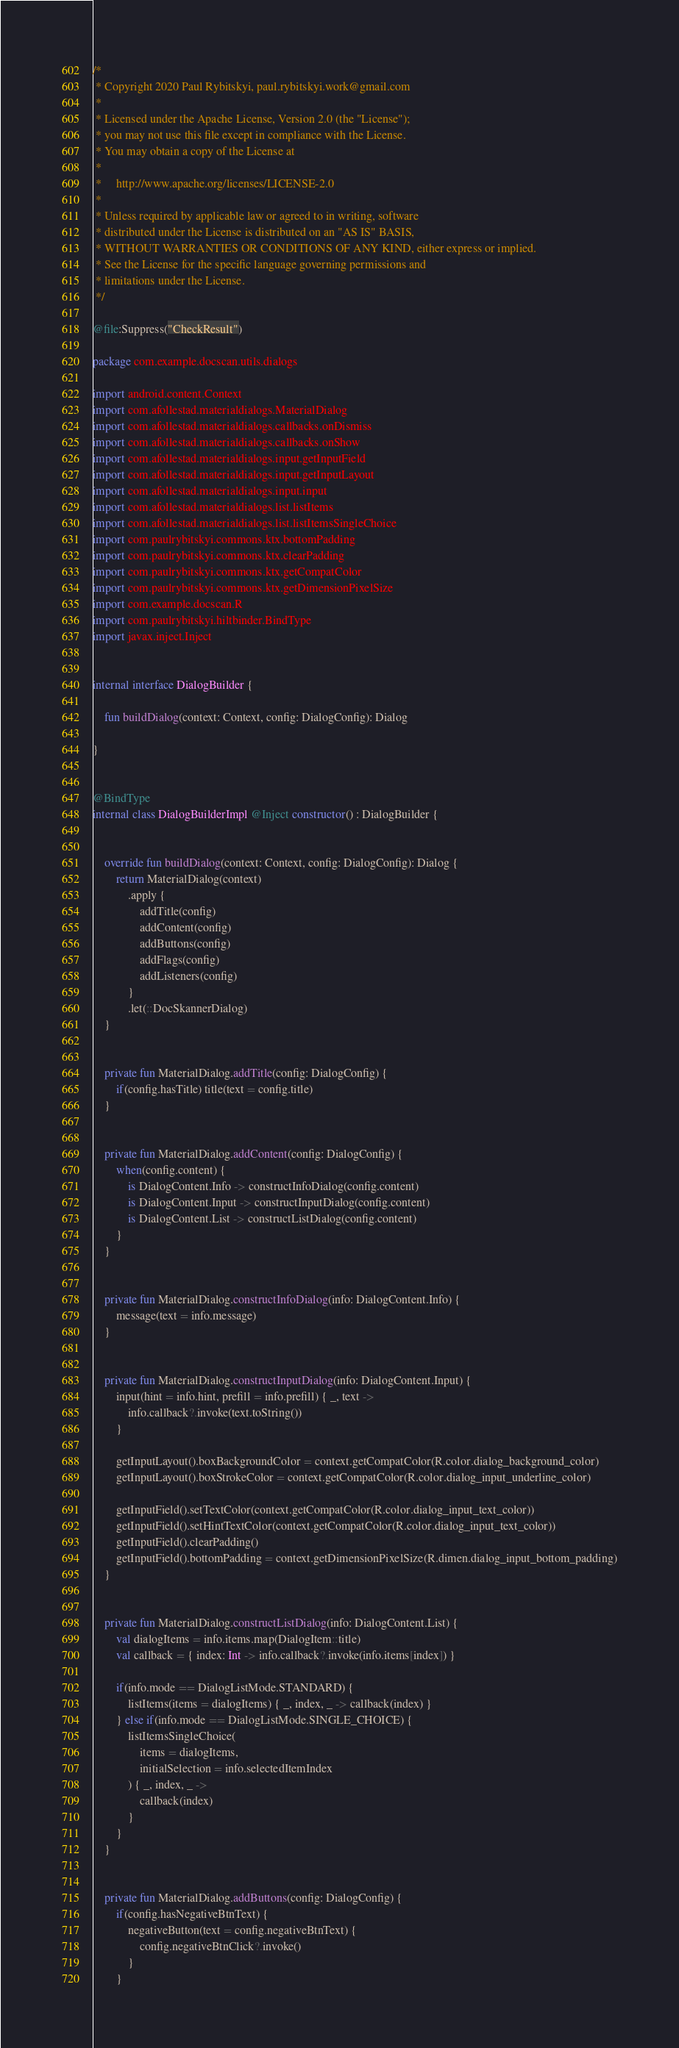<code> <loc_0><loc_0><loc_500><loc_500><_Kotlin_>/*
 * Copyright 2020 Paul Rybitskyi, paul.rybitskyi.work@gmail.com
 *
 * Licensed under the Apache License, Version 2.0 (the "License");
 * you may not use this file except in compliance with the License.
 * You may obtain a copy of the License at
 *
 *     http://www.apache.org/licenses/LICENSE-2.0
 *
 * Unless required by applicable law or agreed to in writing, software
 * distributed under the License is distributed on an "AS IS" BASIS,
 * WITHOUT WARRANTIES OR CONDITIONS OF ANY KIND, either express or implied.
 * See the License for the specific language governing permissions and
 * limitations under the License.
 */

@file:Suppress("CheckResult")

package com.example.docscan.utils.dialogs

import android.content.Context
import com.afollestad.materialdialogs.MaterialDialog
import com.afollestad.materialdialogs.callbacks.onDismiss
import com.afollestad.materialdialogs.callbacks.onShow
import com.afollestad.materialdialogs.input.getInputField
import com.afollestad.materialdialogs.input.getInputLayout
import com.afollestad.materialdialogs.input.input
import com.afollestad.materialdialogs.list.listItems
import com.afollestad.materialdialogs.list.listItemsSingleChoice
import com.paulrybitskyi.commons.ktx.bottomPadding
import com.paulrybitskyi.commons.ktx.clearPadding
import com.paulrybitskyi.commons.ktx.getCompatColor
import com.paulrybitskyi.commons.ktx.getDimensionPixelSize
import com.example.docscan.R
import com.paulrybitskyi.hiltbinder.BindType
import javax.inject.Inject


internal interface DialogBuilder {

    fun buildDialog(context: Context, config: DialogConfig): Dialog

}


@BindType
internal class DialogBuilderImpl @Inject constructor() : DialogBuilder {


    override fun buildDialog(context: Context, config: DialogConfig): Dialog {
        return MaterialDialog(context)
            .apply {
                addTitle(config)
                addContent(config)
                addButtons(config)
                addFlags(config)
                addListeners(config)
            }
            .let(::DocSkannerDialog)
    }


    private fun MaterialDialog.addTitle(config: DialogConfig) {
        if(config.hasTitle) title(text = config.title)
    }


    private fun MaterialDialog.addContent(config: DialogConfig) {
        when(config.content) {
            is DialogContent.Info -> constructInfoDialog(config.content)
            is DialogContent.Input -> constructInputDialog(config.content)
            is DialogContent.List -> constructListDialog(config.content)
        }
    }


    private fun MaterialDialog.constructInfoDialog(info: DialogContent.Info) {
        message(text = info.message)
    }


    private fun MaterialDialog.constructInputDialog(info: DialogContent.Input) {
        input(hint = info.hint, prefill = info.prefill) { _, text ->
            info.callback?.invoke(text.toString())
        }

        getInputLayout().boxBackgroundColor = context.getCompatColor(R.color.dialog_background_color)
        getInputLayout().boxStrokeColor = context.getCompatColor(R.color.dialog_input_underline_color)

        getInputField().setTextColor(context.getCompatColor(R.color.dialog_input_text_color))
        getInputField().setHintTextColor(context.getCompatColor(R.color.dialog_input_text_color))
        getInputField().clearPadding()
        getInputField().bottomPadding = context.getDimensionPixelSize(R.dimen.dialog_input_bottom_padding)
    }


    private fun MaterialDialog.constructListDialog(info: DialogContent.List) {
        val dialogItems = info.items.map(DialogItem::title)
        val callback = { index: Int -> info.callback?.invoke(info.items[index]) }

        if(info.mode == DialogListMode.STANDARD) {
            listItems(items = dialogItems) { _, index, _ -> callback(index) }
        } else if(info.mode == DialogListMode.SINGLE_CHOICE) {
            listItemsSingleChoice(
                items = dialogItems,
                initialSelection = info.selectedItemIndex
            ) { _, index, _ ->
                callback(index)
            }
        }
    }


    private fun MaterialDialog.addButtons(config: DialogConfig) {
        if(config.hasNegativeBtnText) {
            negativeButton(text = config.negativeBtnText) {
                config.negativeBtnClick?.invoke()
            }
        }
</code> 